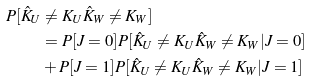Convert formula to latex. <formula><loc_0><loc_0><loc_500><loc_500>P [ \hat { K } _ { U } & \neq K _ { U } \hat { K } _ { W } \neq K _ { W } ] \\ & = P [ J = 0 ] P [ \hat { K } _ { U } \neq K _ { U } \hat { K } _ { W } \neq K _ { W } | J = 0 ] \\ & + P [ J = 1 ] P [ \hat { K } _ { U } \neq K _ { U } \hat { K } _ { W } \neq K _ { W } | J = 1 ]</formula> 